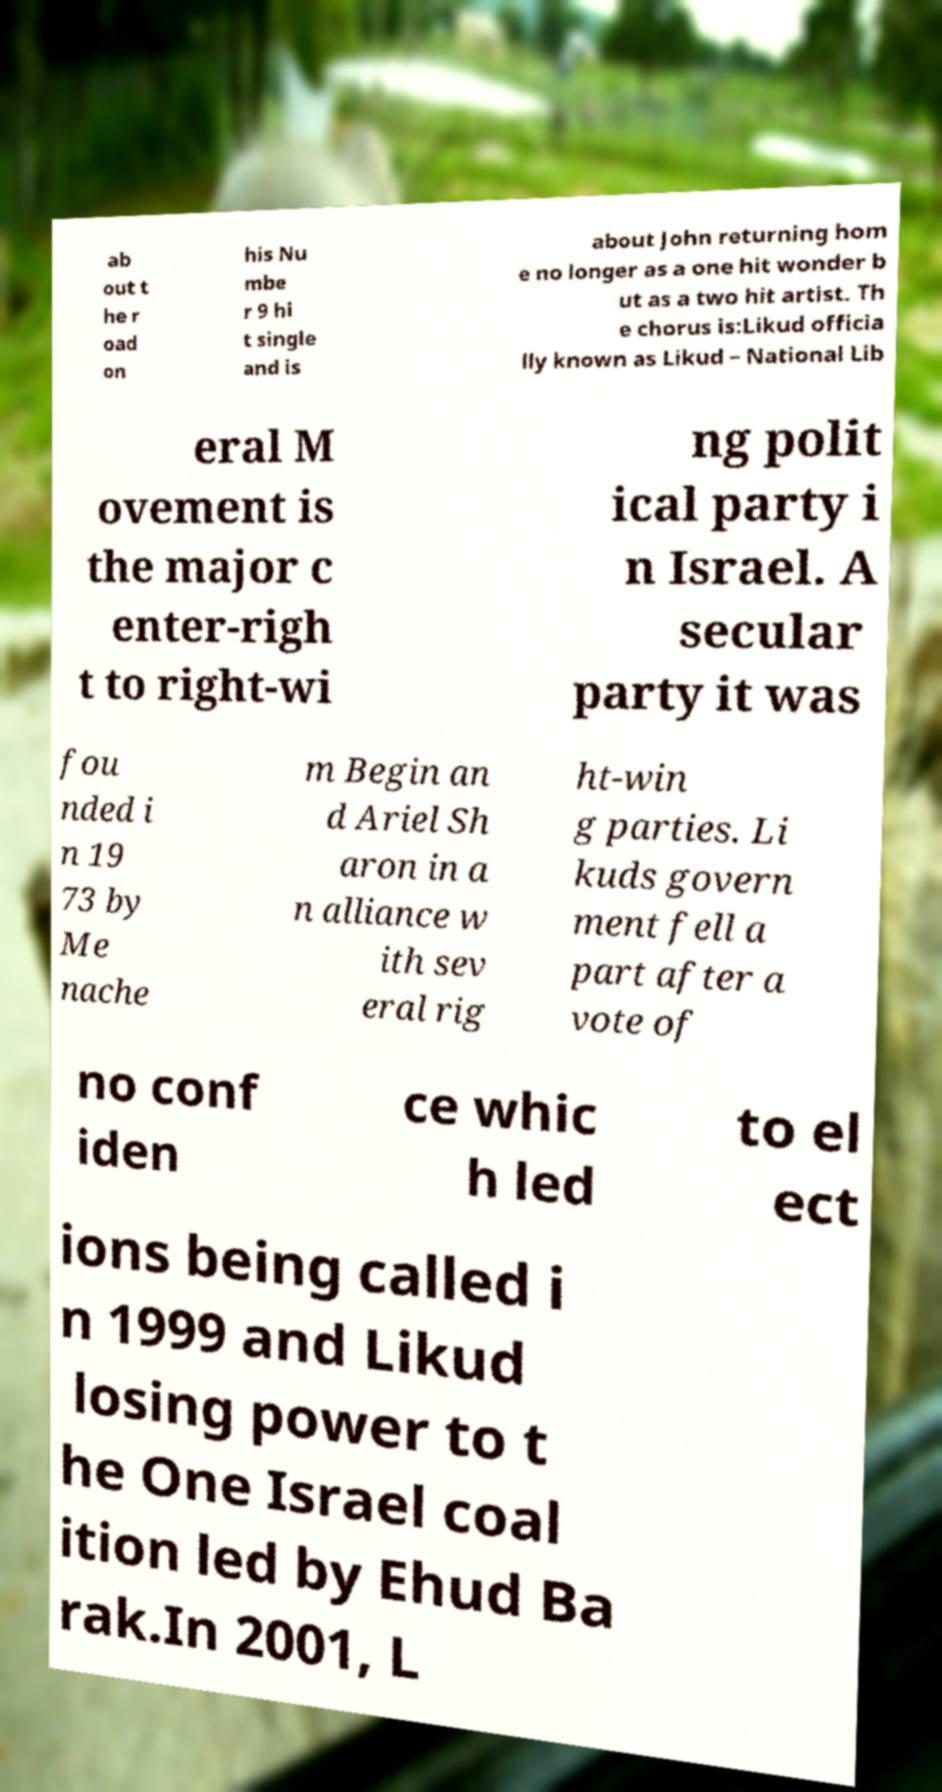Please identify and transcribe the text found in this image. ab out t he r oad on his Nu mbe r 9 hi t single and is about John returning hom e no longer as a one hit wonder b ut as a two hit artist. Th e chorus is:Likud officia lly known as Likud – National Lib eral M ovement is the major c enter-righ t to right-wi ng polit ical party i n Israel. A secular party it was fou nded i n 19 73 by Me nache m Begin an d Ariel Sh aron in a n alliance w ith sev eral rig ht-win g parties. Li kuds govern ment fell a part after a vote of no conf iden ce whic h led to el ect ions being called i n 1999 and Likud losing power to t he One Israel coal ition led by Ehud Ba rak.In 2001, L 